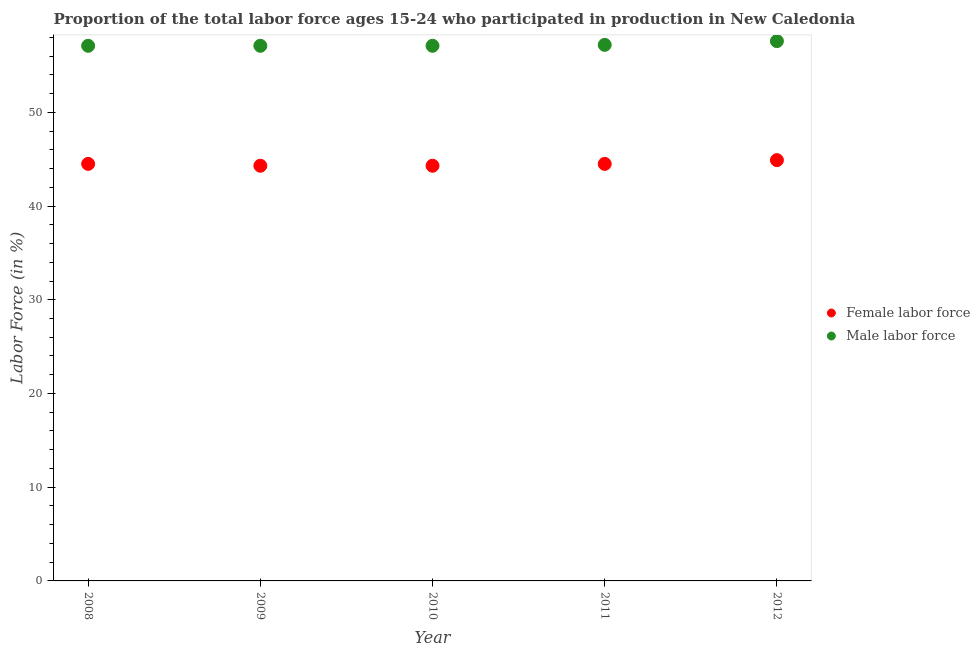How many different coloured dotlines are there?
Offer a very short reply. 2. Is the number of dotlines equal to the number of legend labels?
Ensure brevity in your answer.  Yes. What is the percentage of male labour force in 2011?
Offer a terse response. 57.2. Across all years, what is the maximum percentage of female labor force?
Ensure brevity in your answer.  44.9. Across all years, what is the minimum percentage of male labour force?
Keep it short and to the point. 57.1. What is the total percentage of male labour force in the graph?
Offer a terse response. 286.1. What is the difference between the percentage of male labour force in 2008 and that in 2011?
Your answer should be compact. -0.1. What is the difference between the percentage of female labor force in 2011 and the percentage of male labour force in 2012?
Keep it short and to the point. -13.1. What is the average percentage of male labour force per year?
Keep it short and to the point. 57.22. In the year 2008, what is the difference between the percentage of female labor force and percentage of male labour force?
Offer a terse response. -12.6. In how many years, is the percentage of male labour force greater than 26 %?
Give a very brief answer. 5. What is the ratio of the percentage of male labour force in 2008 to that in 2012?
Your response must be concise. 0.99. Is the percentage of female labor force in 2010 less than that in 2011?
Provide a succinct answer. Yes. What is the difference between the highest and the second highest percentage of female labor force?
Your answer should be compact. 0.4. What is the difference between the highest and the lowest percentage of female labor force?
Provide a short and direct response. 0.6. Is the sum of the percentage of female labor force in 2009 and 2012 greater than the maximum percentage of male labour force across all years?
Provide a short and direct response. Yes. Does the percentage of female labor force monotonically increase over the years?
Give a very brief answer. No. Is the percentage of male labour force strictly greater than the percentage of female labor force over the years?
Your answer should be very brief. Yes. Are the values on the major ticks of Y-axis written in scientific E-notation?
Offer a terse response. No. Does the graph contain any zero values?
Make the answer very short. No. How many legend labels are there?
Give a very brief answer. 2. What is the title of the graph?
Provide a succinct answer. Proportion of the total labor force ages 15-24 who participated in production in New Caledonia. Does "Rural" appear as one of the legend labels in the graph?
Ensure brevity in your answer.  No. What is the label or title of the X-axis?
Keep it short and to the point. Year. What is the label or title of the Y-axis?
Give a very brief answer. Labor Force (in %). What is the Labor Force (in %) of Female labor force in 2008?
Ensure brevity in your answer.  44.5. What is the Labor Force (in %) in Male labor force in 2008?
Ensure brevity in your answer.  57.1. What is the Labor Force (in %) of Female labor force in 2009?
Provide a succinct answer. 44.3. What is the Labor Force (in %) of Male labor force in 2009?
Keep it short and to the point. 57.1. What is the Labor Force (in %) of Female labor force in 2010?
Offer a very short reply. 44.3. What is the Labor Force (in %) in Male labor force in 2010?
Offer a very short reply. 57.1. What is the Labor Force (in %) of Female labor force in 2011?
Offer a very short reply. 44.5. What is the Labor Force (in %) in Male labor force in 2011?
Your response must be concise. 57.2. What is the Labor Force (in %) of Female labor force in 2012?
Provide a succinct answer. 44.9. What is the Labor Force (in %) in Male labor force in 2012?
Your answer should be compact. 57.6. Across all years, what is the maximum Labor Force (in %) of Female labor force?
Give a very brief answer. 44.9. Across all years, what is the maximum Labor Force (in %) of Male labor force?
Offer a terse response. 57.6. Across all years, what is the minimum Labor Force (in %) of Female labor force?
Give a very brief answer. 44.3. Across all years, what is the minimum Labor Force (in %) of Male labor force?
Your answer should be very brief. 57.1. What is the total Labor Force (in %) in Female labor force in the graph?
Your answer should be compact. 222.5. What is the total Labor Force (in %) of Male labor force in the graph?
Provide a short and direct response. 286.1. What is the difference between the Labor Force (in %) of Female labor force in 2008 and that in 2010?
Give a very brief answer. 0.2. What is the difference between the Labor Force (in %) of Female labor force in 2008 and that in 2011?
Keep it short and to the point. 0. What is the difference between the Labor Force (in %) of Female labor force in 2008 and that in 2012?
Give a very brief answer. -0.4. What is the difference between the Labor Force (in %) in Female labor force in 2009 and that in 2010?
Give a very brief answer. 0. What is the difference between the Labor Force (in %) in Female labor force in 2009 and that in 2011?
Ensure brevity in your answer.  -0.2. What is the difference between the Labor Force (in %) of Male labor force in 2009 and that in 2011?
Offer a terse response. -0.1. What is the difference between the Labor Force (in %) of Female labor force in 2009 and that in 2012?
Offer a terse response. -0.6. What is the difference between the Labor Force (in %) of Male labor force in 2010 and that in 2011?
Offer a terse response. -0.1. What is the difference between the Labor Force (in %) of Female labor force in 2008 and the Labor Force (in %) of Male labor force in 2011?
Offer a terse response. -12.7. What is the difference between the Labor Force (in %) of Female labor force in 2008 and the Labor Force (in %) of Male labor force in 2012?
Give a very brief answer. -13.1. What is the difference between the Labor Force (in %) of Female labor force in 2009 and the Labor Force (in %) of Male labor force in 2012?
Make the answer very short. -13.3. What is the difference between the Labor Force (in %) in Female labor force in 2010 and the Labor Force (in %) in Male labor force in 2011?
Keep it short and to the point. -12.9. What is the difference between the Labor Force (in %) in Female labor force in 2011 and the Labor Force (in %) in Male labor force in 2012?
Give a very brief answer. -13.1. What is the average Labor Force (in %) of Female labor force per year?
Provide a short and direct response. 44.5. What is the average Labor Force (in %) in Male labor force per year?
Your answer should be very brief. 57.22. In the year 2008, what is the difference between the Labor Force (in %) in Female labor force and Labor Force (in %) in Male labor force?
Provide a succinct answer. -12.6. In the year 2010, what is the difference between the Labor Force (in %) in Female labor force and Labor Force (in %) in Male labor force?
Offer a terse response. -12.8. What is the ratio of the Labor Force (in %) of Male labor force in 2008 to that in 2010?
Offer a terse response. 1. What is the ratio of the Labor Force (in %) of Female labor force in 2008 to that in 2011?
Your answer should be very brief. 1. What is the ratio of the Labor Force (in %) in Male labor force in 2008 to that in 2011?
Provide a short and direct response. 1. What is the ratio of the Labor Force (in %) in Female labor force in 2008 to that in 2012?
Provide a short and direct response. 0.99. What is the ratio of the Labor Force (in %) in Female labor force in 2009 to that in 2010?
Give a very brief answer. 1. What is the ratio of the Labor Force (in %) in Male labor force in 2009 to that in 2011?
Your answer should be compact. 1. What is the ratio of the Labor Force (in %) in Female labor force in 2009 to that in 2012?
Provide a succinct answer. 0.99. What is the ratio of the Labor Force (in %) in Male labor force in 2009 to that in 2012?
Your response must be concise. 0.99. What is the ratio of the Labor Force (in %) in Male labor force in 2010 to that in 2011?
Your response must be concise. 1. What is the ratio of the Labor Force (in %) in Female labor force in 2010 to that in 2012?
Make the answer very short. 0.99. What is the ratio of the Labor Force (in %) in Male labor force in 2010 to that in 2012?
Make the answer very short. 0.99. What is the difference between the highest and the second highest Labor Force (in %) in Female labor force?
Offer a terse response. 0.4. What is the difference between the highest and the second highest Labor Force (in %) of Male labor force?
Provide a short and direct response. 0.4. 